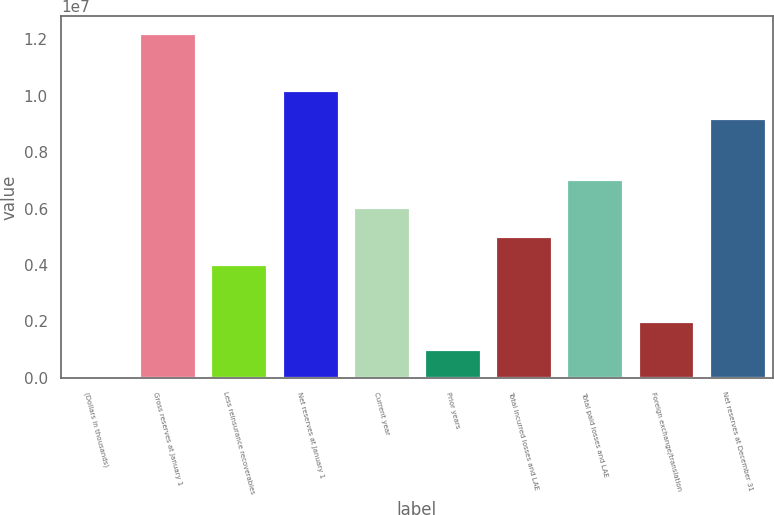<chart> <loc_0><loc_0><loc_500><loc_500><bar_chart><fcel>(Dollars in thousands)<fcel>Gross reserves at January 1<fcel>Less reinsurance recoverables<fcel>Net reserves at January 1<fcel>Current year<fcel>Prior years<fcel>Total incurred losses and LAE<fcel>Total paid losses and LAE<fcel>Foreign exchange/translation<fcel>Net reserves at December 31<nl><fcel>2013<fcel>1.22195e+07<fcel>4.02883e+06<fcel>1.02061e+07<fcel>6.04224e+06<fcel>1.00872e+06<fcel>5.03553e+06<fcel>7.04894e+06<fcel>2.01542e+06<fcel>9.19937e+06<nl></chart> 